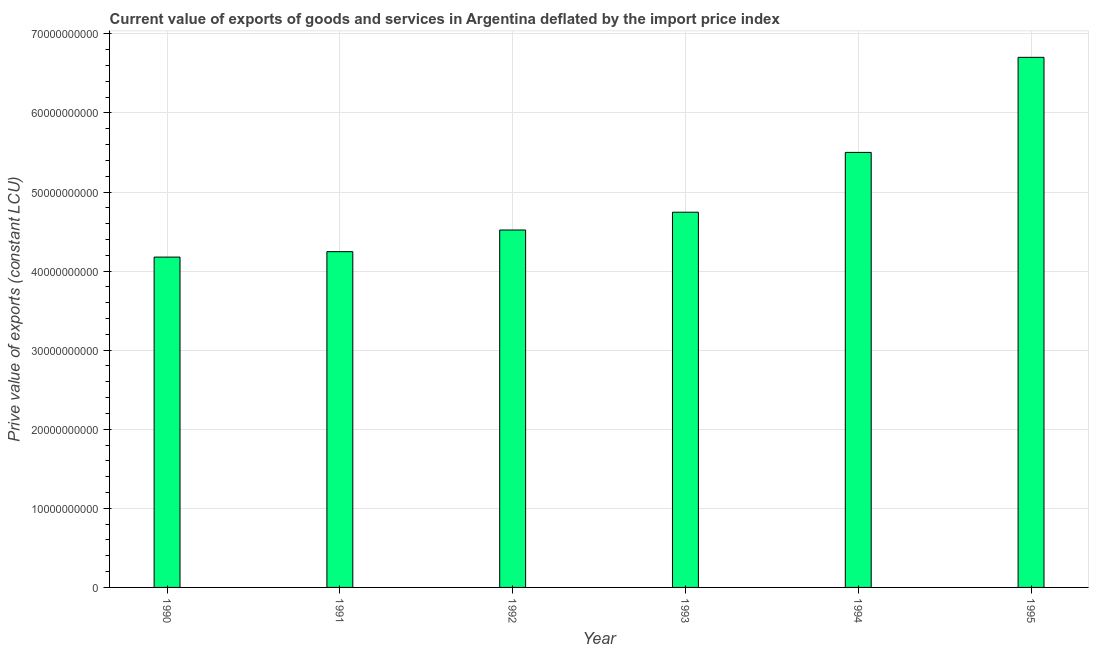What is the title of the graph?
Ensure brevity in your answer.  Current value of exports of goods and services in Argentina deflated by the import price index. What is the label or title of the X-axis?
Keep it short and to the point. Year. What is the label or title of the Y-axis?
Provide a succinct answer. Prive value of exports (constant LCU). What is the price value of exports in 1992?
Offer a very short reply. 4.52e+1. Across all years, what is the maximum price value of exports?
Give a very brief answer. 6.70e+1. Across all years, what is the minimum price value of exports?
Your answer should be very brief. 4.18e+1. In which year was the price value of exports maximum?
Your answer should be compact. 1995. What is the sum of the price value of exports?
Provide a succinct answer. 2.99e+11. What is the difference between the price value of exports in 1994 and 1995?
Ensure brevity in your answer.  -1.20e+1. What is the average price value of exports per year?
Ensure brevity in your answer.  4.98e+1. What is the median price value of exports?
Make the answer very short. 4.63e+1. Is the price value of exports in 1992 less than that in 1995?
Ensure brevity in your answer.  Yes. Is the difference between the price value of exports in 1991 and 1995 greater than the difference between any two years?
Your response must be concise. No. What is the difference between the highest and the second highest price value of exports?
Provide a succinct answer. 1.20e+1. Is the sum of the price value of exports in 1991 and 1994 greater than the maximum price value of exports across all years?
Ensure brevity in your answer.  Yes. What is the difference between the highest and the lowest price value of exports?
Give a very brief answer. 2.53e+1. In how many years, is the price value of exports greater than the average price value of exports taken over all years?
Your response must be concise. 2. Are all the bars in the graph horizontal?
Make the answer very short. No. How many years are there in the graph?
Your answer should be very brief. 6. What is the difference between two consecutive major ticks on the Y-axis?
Your answer should be very brief. 1.00e+1. What is the Prive value of exports (constant LCU) of 1990?
Provide a short and direct response. 4.18e+1. What is the Prive value of exports (constant LCU) of 1991?
Your answer should be very brief. 4.25e+1. What is the Prive value of exports (constant LCU) in 1992?
Give a very brief answer. 4.52e+1. What is the Prive value of exports (constant LCU) of 1993?
Offer a very short reply. 4.74e+1. What is the Prive value of exports (constant LCU) of 1994?
Your answer should be very brief. 5.50e+1. What is the Prive value of exports (constant LCU) in 1995?
Ensure brevity in your answer.  6.70e+1. What is the difference between the Prive value of exports (constant LCU) in 1990 and 1991?
Give a very brief answer. -6.88e+08. What is the difference between the Prive value of exports (constant LCU) in 1990 and 1992?
Your answer should be very brief. -3.43e+09. What is the difference between the Prive value of exports (constant LCU) in 1990 and 1993?
Offer a terse response. -5.68e+09. What is the difference between the Prive value of exports (constant LCU) in 1990 and 1994?
Keep it short and to the point. -1.32e+1. What is the difference between the Prive value of exports (constant LCU) in 1990 and 1995?
Offer a terse response. -2.53e+1. What is the difference between the Prive value of exports (constant LCU) in 1991 and 1992?
Give a very brief answer. -2.74e+09. What is the difference between the Prive value of exports (constant LCU) in 1991 and 1993?
Offer a terse response. -4.99e+09. What is the difference between the Prive value of exports (constant LCU) in 1991 and 1994?
Your answer should be compact. -1.26e+1. What is the difference between the Prive value of exports (constant LCU) in 1991 and 1995?
Ensure brevity in your answer.  -2.46e+1. What is the difference between the Prive value of exports (constant LCU) in 1992 and 1993?
Provide a succinct answer. -2.25e+09. What is the difference between the Prive value of exports (constant LCU) in 1992 and 1994?
Your answer should be compact. -9.81e+09. What is the difference between the Prive value of exports (constant LCU) in 1992 and 1995?
Provide a short and direct response. -2.18e+1. What is the difference between the Prive value of exports (constant LCU) in 1993 and 1994?
Provide a short and direct response. -7.57e+09. What is the difference between the Prive value of exports (constant LCU) in 1993 and 1995?
Keep it short and to the point. -1.96e+1. What is the difference between the Prive value of exports (constant LCU) in 1994 and 1995?
Make the answer very short. -1.20e+1. What is the ratio of the Prive value of exports (constant LCU) in 1990 to that in 1992?
Your response must be concise. 0.92. What is the ratio of the Prive value of exports (constant LCU) in 1990 to that in 1993?
Your answer should be compact. 0.88. What is the ratio of the Prive value of exports (constant LCU) in 1990 to that in 1994?
Your response must be concise. 0.76. What is the ratio of the Prive value of exports (constant LCU) in 1990 to that in 1995?
Provide a succinct answer. 0.62. What is the ratio of the Prive value of exports (constant LCU) in 1991 to that in 1992?
Offer a very short reply. 0.94. What is the ratio of the Prive value of exports (constant LCU) in 1991 to that in 1993?
Make the answer very short. 0.9. What is the ratio of the Prive value of exports (constant LCU) in 1991 to that in 1994?
Keep it short and to the point. 0.77. What is the ratio of the Prive value of exports (constant LCU) in 1991 to that in 1995?
Offer a terse response. 0.63. What is the ratio of the Prive value of exports (constant LCU) in 1992 to that in 1993?
Provide a succinct answer. 0.95. What is the ratio of the Prive value of exports (constant LCU) in 1992 to that in 1994?
Ensure brevity in your answer.  0.82. What is the ratio of the Prive value of exports (constant LCU) in 1992 to that in 1995?
Your answer should be compact. 0.67. What is the ratio of the Prive value of exports (constant LCU) in 1993 to that in 1994?
Provide a short and direct response. 0.86. What is the ratio of the Prive value of exports (constant LCU) in 1993 to that in 1995?
Make the answer very short. 0.71. What is the ratio of the Prive value of exports (constant LCU) in 1994 to that in 1995?
Provide a succinct answer. 0.82. 